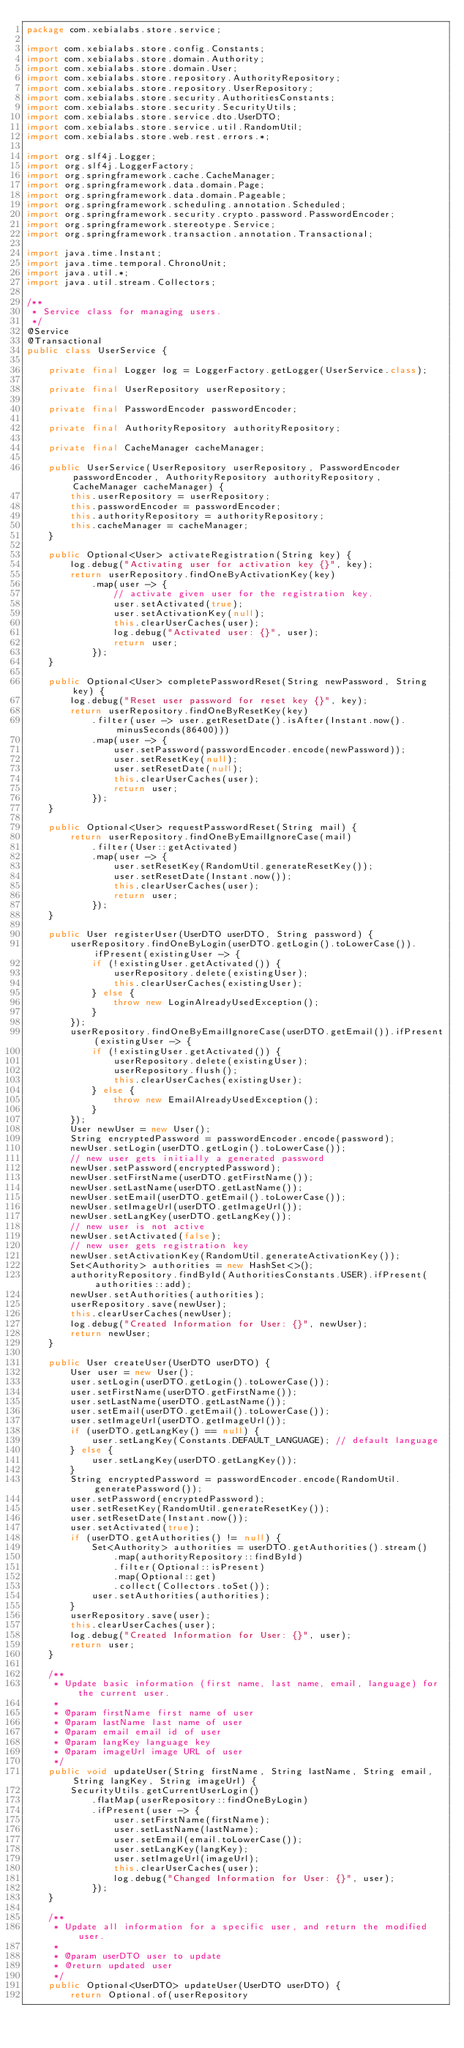Convert code to text. <code><loc_0><loc_0><loc_500><loc_500><_Java_>package com.xebialabs.store.service;

import com.xebialabs.store.config.Constants;
import com.xebialabs.store.domain.Authority;
import com.xebialabs.store.domain.User;
import com.xebialabs.store.repository.AuthorityRepository;
import com.xebialabs.store.repository.UserRepository;
import com.xebialabs.store.security.AuthoritiesConstants;
import com.xebialabs.store.security.SecurityUtils;
import com.xebialabs.store.service.dto.UserDTO;
import com.xebialabs.store.service.util.RandomUtil;
import com.xebialabs.store.web.rest.errors.*;

import org.slf4j.Logger;
import org.slf4j.LoggerFactory;
import org.springframework.cache.CacheManager;
import org.springframework.data.domain.Page;
import org.springframework.data.domain.Pageable;
import org.springframework.scheduling.annotation.Scheduled;
import org.springframework.security.crypto.password.PasswordEncoder;
import org.springframework.stereotype.Service;
import org.springframework.transaction.annotation.Transactional;

import java.time.Instant;
import java.time.temporal.ChronoUnit;
import java.util.*;
import java.util.stream.Collectors;

/**
 * Service class for managing users.
 */
@Service
@Transactional
public class UserService {

    private final Logger log = LoggerFactory.getLogger(UserService.class);

    private final UserRepository userRepository;

    private final PasswordEncoder passwordEncoder;

    private final AuthorityRepository authorityRepository;

    private final CacheManager cacheManager;

    public UserService(UserRepository userRepository, PasswordEncoder passwordEncoder, AuthorityRepository authorityRepository, CacheManager cacheManager) {
        this.userRepository = userRepository;
        this.passwordEncoder = passwordEncoder;
        this.authorityRepository = authorityRepository;
        this.cacheManager = cacheManager;
    }

    public Optional<User> activateRegistration(String key) {
        log.debug("Activating user for activation key {}", key);
        return userRepository.findOneByActivationKey(key)
            .map(user -> {
                // activate given user for the registration key.
                user.setActivated(true);
                user.setActivationKey(null);
                this.clearUserCaches(user);
                log.debug("Activated user: {}", user);
                return user;
            });
    }

    public Optional<User> completePasswordReset(String newPassword, String key) {
        log.debug("Reset user password for reset key {}", key);
        return userRepository.findOneByResetKey(key)
            .filter(user -> user.getResetDate().isAfter(Instant.now().minusSeconds(86400)))
            .map(user -> {
                user.setPassword(passwordEncoder.encode(newPassword));
                user.setResetKey(null);
                user.setResetDate(null);
                this.clearUserCaches(user);
                return user;
            });
    }

    public Optional<User> requestPasswordReset(String mail) {
        return userRepository.findOneByEmailIgnoreCase(mail)
            .filter(User::getActivated)
            .map(user -> {
                user.setResetKey(RandomUtil.generateResetKey());
                user.setResetDate(Instant.now());
                this.clearUserCaches(user);
                return user;
            });
    }

    public User registerUser(UserDTO userDTO, String password) {
        userRepository.findOneByLogin(userDTO.getLogin().toLowerCase()).ifPresent(existingUser -> {
            if (!existingUser.getActivated()) {
                userRepository.delete(existingUser);
                this.clearUserCaches(existingUser);
            } else {
                throw new LoginAlreadyUsedException();
            }
        });
        userRepository.findOneByEmailIgnoreCase(userDTO.getEmail()).ifPresent(existingUser -> {
            if (!existingUser.getActivated()) {
                userRepository.delete(existingUser);
                userRepository.flush();
                this.clearUserCaches(existingUser);
            } else {
                throw new EmailAlreadyUsedException();
            }
        });
        User newUser = new User();
        String encryptedPassword = passwordEncoder.encode(password);
        newUser.setLogin(userDTO.getLogin().toLowerCase());
        // new user gets initially a generated password
        newUser.setPassword(encryptedPassword);
        newUser.setFirstName(userDTO.getFirstName());
        newUser.setLastName(userDTO.getLastName());
        newUser.setEmail(userDTO.getEmail().toLowerCase());
        newUser.setImageUrl(userDTO.getImageUrl());
        newUser.setLangKey(userDTO.getLangKey());
        // new user is not active
        newUser.setActivated(false);
        // new user gets registration key
        newUser.setActivationKey(RandomUtil.generateActivationKey());
        Set<Authority> authorities = new HashSet<>();
        authorityRepository.findById(AuthoritiesConstants.USER).ifPresent(authorities::add);
        newUser.setAuthorities(authorities);
        userRepository.save(newUser);
        this.clearUserCaches(newUser);
        log.debug("Created Information for User: {}", newUser);
        return newUser;
    }

    public User createUser(UserDTO userDTO) {
        User user = new User();
        user.setLogin(userDTO.getLogin().toLowerCase());
        user.setFirstName(userDTO.getFirstName());
        user.setLastName(userDTO.getLastName());
        user.setEmail(userDTO.getEmail().toLowerCase());
        user.setImageUrl(userDTO.getImageUrl());
        if (userDTO.getLangKey() == null) {
            user.setLangKey(Constants.DEFAULT_LANGUAGE); // default language
        } else {
            user.setLangKey(userDTO.getLangKey());
        }
        String encryptedPassword = passwordEncoder.encode(RandomUtil.generatePassword());
        user.setPassword(encryptedPassword);
        user.setResetKey(RandomUtil.generateResetKey());
        user.setResetDate(Instant.now());
        user.setActivated(true);
        if (userDTO.getAuthorities() != null) {
            Set<Authority> authorities = userDTO.getAuthorities().stream()
                .map(authorityRepository::findById)
                .filter(Optional::isPresent)
                .map(Optional::get)
                .collect(Collectors.toSet());
            user.setAuthorities(authorities);
        }
        userRepository.save(user);
        this.clearUserCaches(user);
        log.debug("Created Information for User: {}", user);
        return user;
    }

    /**
     * Update basic information (first name, last name, email, language) for the current user.
     *
     * @param firstName first name of user
     * @param lastName last name of user
     * @param email email id of user
     * @param langKey language key
     * @param imageUrl image URL of user
     */
    public void updateUser(String firstName, String lastName, String email, String langKey, String imageUrl) {
        SecurityUtils.getCurrentUserLogin()
            .flatMap(userRepository::findOneByLogin)
            .ifPresent(user -> {
                user.setFirstName(firstName);
                user.setLastName(lastName);
                user.setEmail(email.toLowerCase());
                user.setLangKey(langKey);
                user.setImageUrl(imageUrl);
                this.clearUserCaches(user);
                log.debug("Changed Information for User: {}", user);
            });
    }

    /**
     * Update all information for a specific user, and return the modified user.
     *
     * @param userDTO user to update
     * @return updated user
     */
    public Optional<UserDTO> updateUser(UserDTO userDTO) {
        return Optional.of(userRepository</code> 